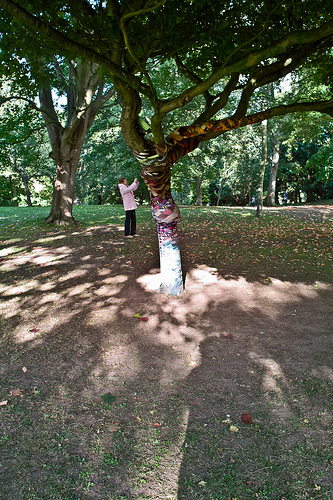<image>
Can you confirm if the man is behind the tree? Yes. From this viewpoint, the man is positioned behind the tree, with the tree partially or fully occluding the man. Is there a person in front of the tree? No. The person is not in front of the tree. The spatial positioning shows a different relationship between these objects. 